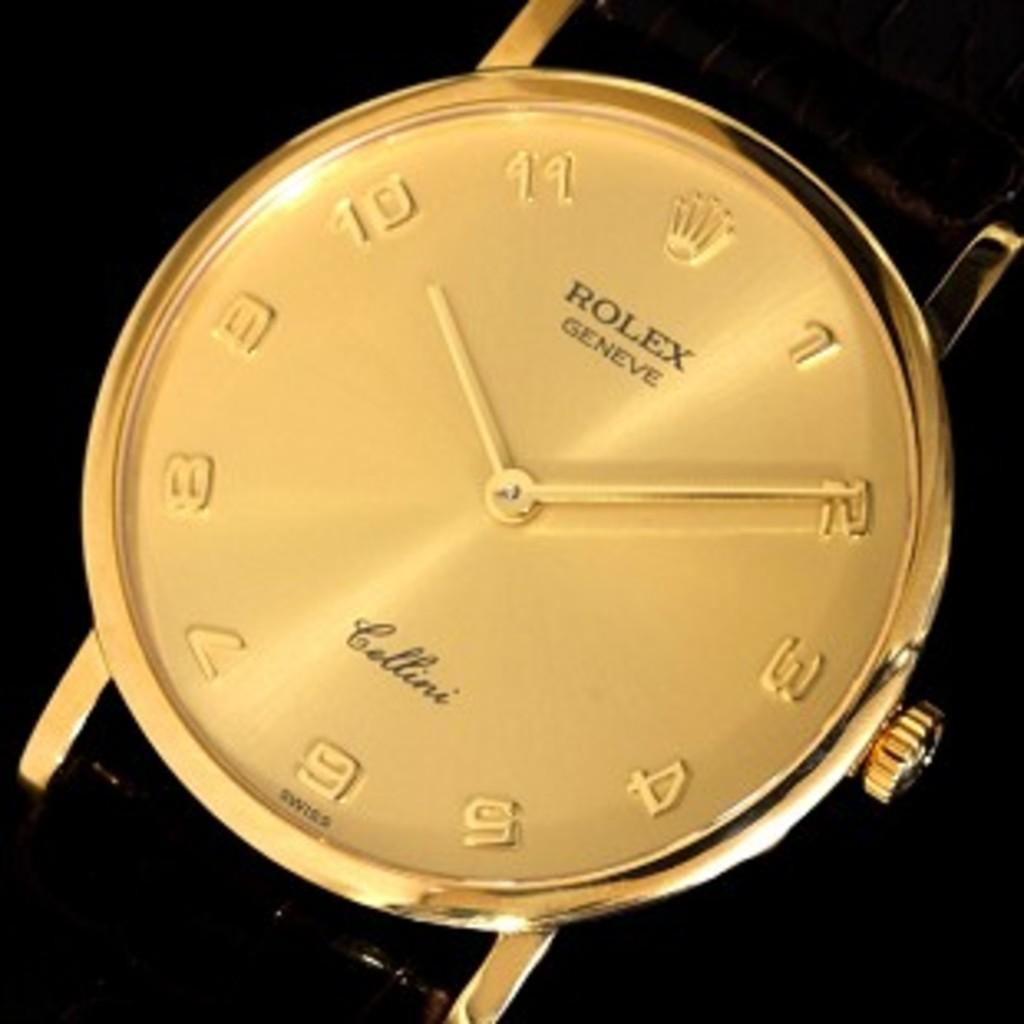<image>
Describe the image concisely. Rolex is plainly written on the top of a watch. 